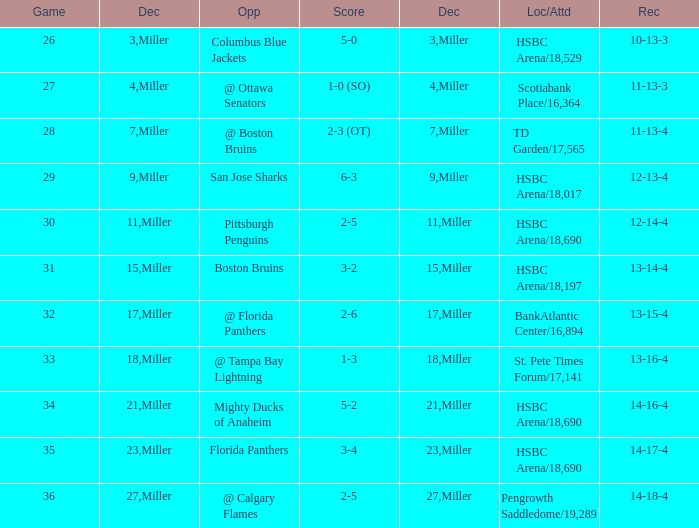Name the least december for hsbc arena/18,017 9.0. 